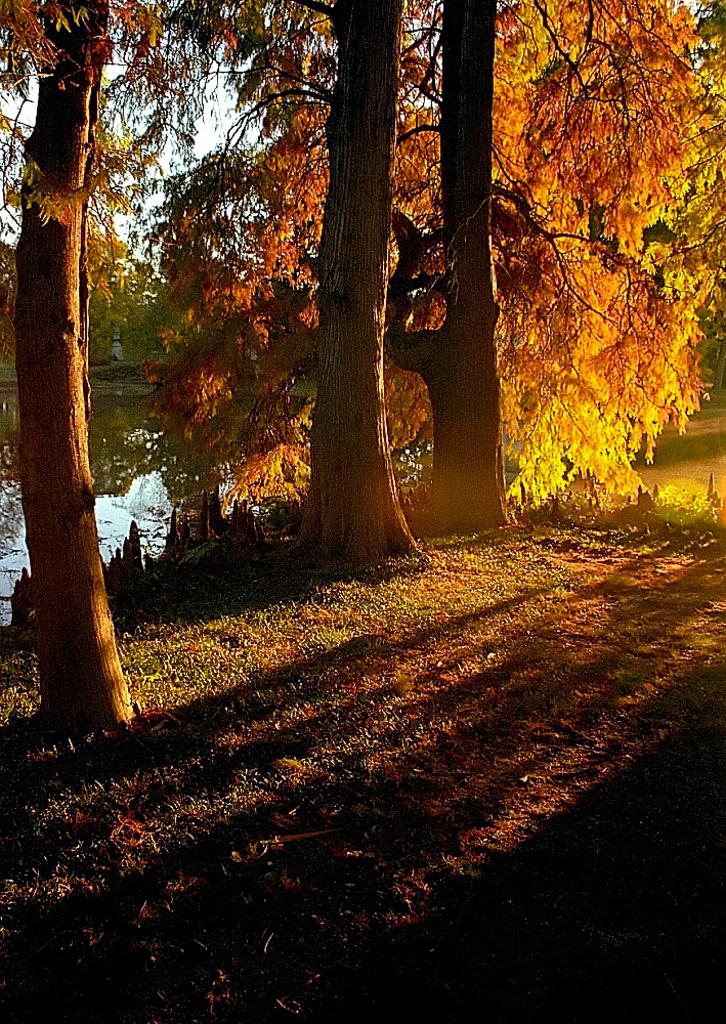What type of vegetation can be seen in the image? There are trees in the image. What colors are present on the trees? The trees have green, orange, and yellow colors. What can be seen in the background of the image? There is water and grass visible in the background of the image. What type of jam is being spread on the ghost in the image? There is no jam or ghost present in the image; it features trees with green, orange, and yellow colors, and a background with water and grass. 